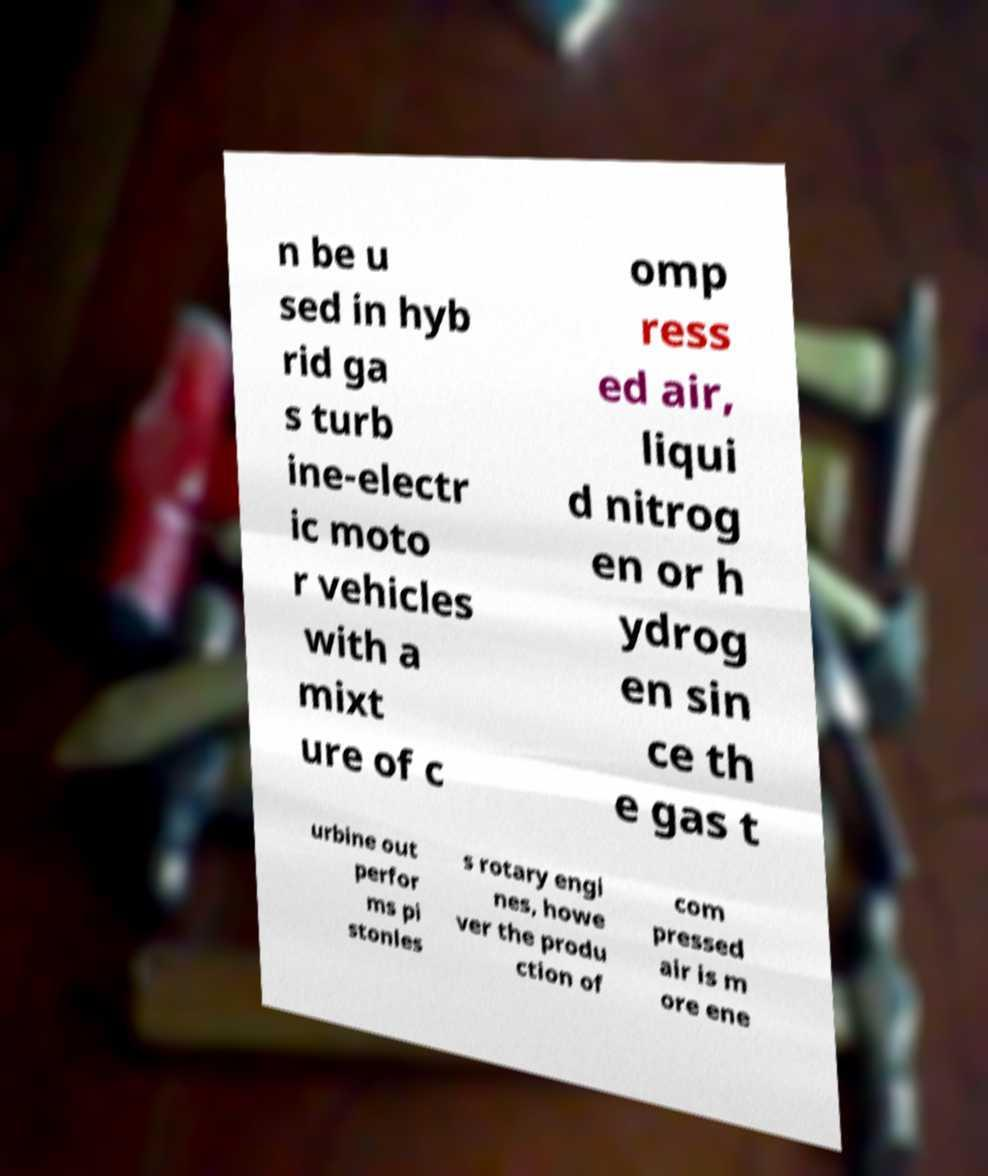There's text embedded in this image that I need extracted. Can you transcribe it verbatim? n be u sed in hyb rid ga s turb ine-electr ic moto r vehicles with a mixt ure of c omp ress ed air, liqui d nitrog en or h ydrog en sin ce th e gas t urbine out perfor ms pi stonles s rotary engi nes, howe ver the produ ction of com pressed air is m ore ene 